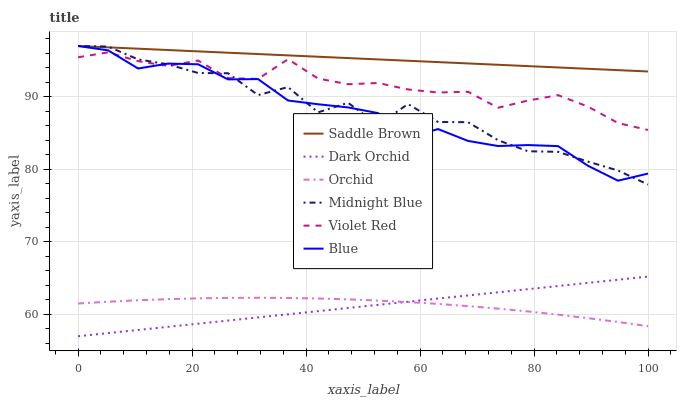Does Dark Orchid have the minimum area under the curve?
Answer yes or no. Yes. Does Saddle Brown have the maximum area under the curve?
Answer yes or no. Yes. Does Violet Red have the minimum area under the curve?
Answer yes or no. No. Does Violet Red have the maximum area under the curve?
Answer yes or no. No. Is Dark Orchid the smoothest?
Answer yes or no. Yes. Is Midnight Blue the roughest?
Answer yes or no. Yes. Is Violet Red the smoothest?
Answer yes or no. No. Is Violet Red the roughest?
Answer yes or no. No. Does Violet Red have the lowest value?
Answer yes or no. No. Does Violet Red have the highest value?
Answer yes or no. No. Is Orchid less than Blue?
Answer yes or no. Yes. Is Midnight Blue greater than Dark Orchid?
Answer yes or no. Yes. Does Orchid intersect Blue?
Answer yes or no. No. 